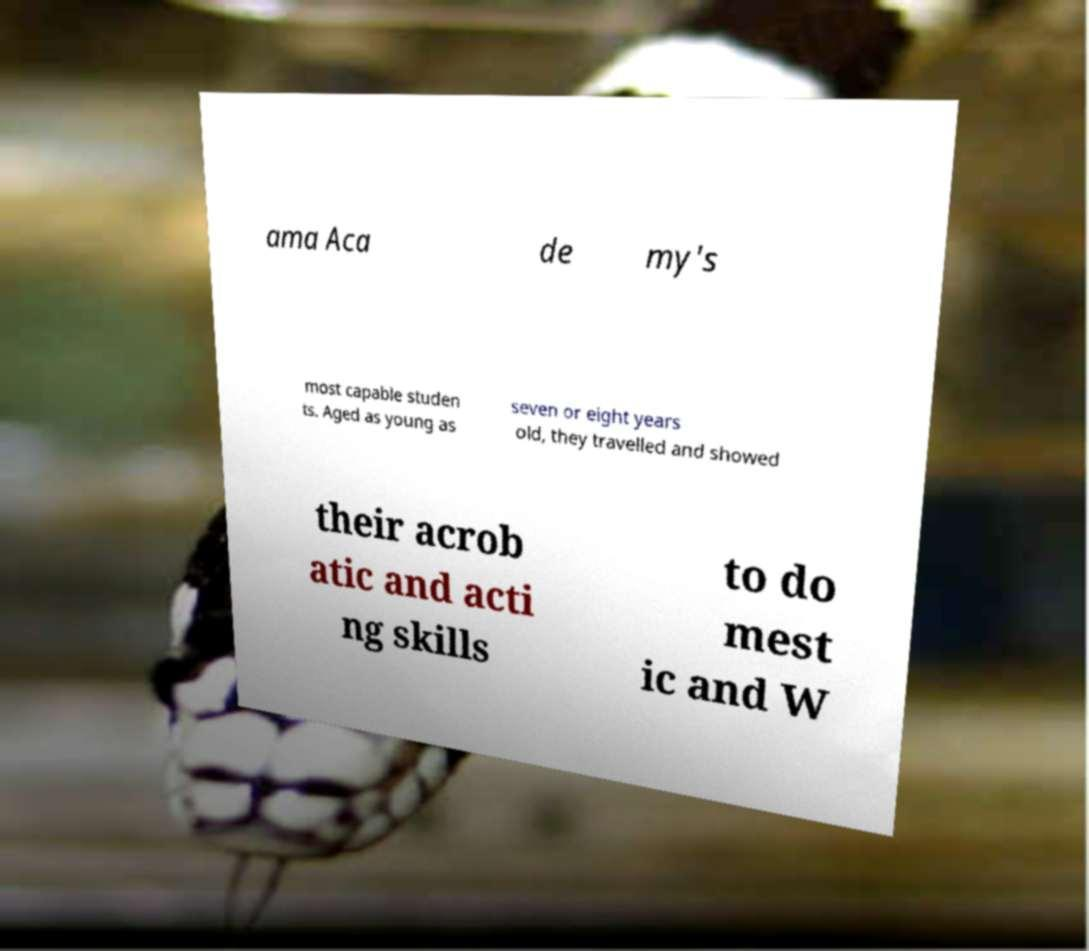For documentation purposes, I need the text within this image transcribed. Could you provide that? ama Aca de my's most capable studen ts. Aged as young as seven or eight years old, they travelled and showed their acrob atic and acti ng skills to do mest ic and W 